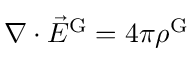<formula> <loc_0><loc_0><loc_500><loc_500>\nabla \cdot { \vec { E } } ^ { G } = 4 \pi \rho ^ { G }</formula> 